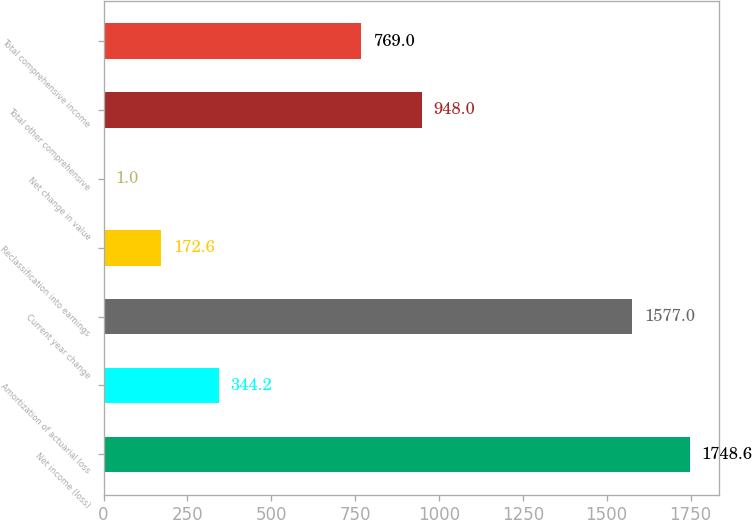Convert chart to OTSL. <chart><loc_0><loc_0><loc_500><loc_500><bar_chart><fcel>Net income (loss)<fcel>Amortization of actuarial loss<fcel>Current year change<fcel>Reclassification into earnings<fcel>Net change in value<fcel>Total other comprehensive<fcel>Total comprehensive income<nl><fcel>1748.6<fcel>344.2<fcel>1577<fcel>172.6<fcel>1<fcel>948<fcel>769<nl></chart> 